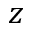Convert formula to latex. <formula><loc_0><loc_0><loc_500><loc_500>z</formula> 